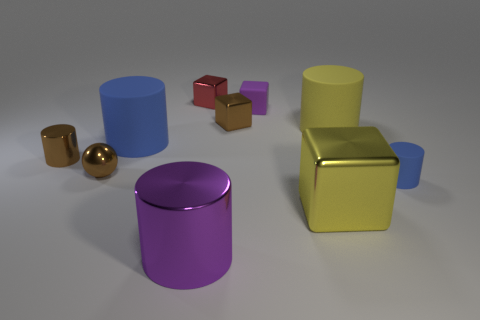Is the small purple thing made of the same material as the cylinder that is in front of the big yellow metal cube?
Give a very brief answer. No. There is a big object that is the same color as the matte cube; what shape is it?
Your answer should be very brief. Cylinder. What number of red shiny blocks have the same size as the purple shiny cylinder?
Ensure brevity in your answer.  0. Is the number of yellow rubber things in front of the large purple shiny cylinder less than the number of gray shiny blocks?
Ensure brevity in your answer.  No. There is a brown metallic cylinder; how many tiny shiny balls are in front of it?
Give a very brief answer. 1. How big is the blue matte thing that is in front of the tiny cylinder on the left side of the small cylinder that is on the right side of the big block?
Provide a short and direct response. Small. Is the shape of the big purple metallic object the same as the rubber object to the left of the purple block?
Your answer should be very brief. Yes. There is a brown cylinder that is made of the same material as the red object; what size is it?
Keep it short and to the point. Small. What material is the large cylinder that is in front of the blue rubber thing that is right of the brown thing that is behind the yellow rubber cylinder made of?
Keep it short and to the point. Metal. What number of metallic things are either large cubes or blue cylinders?
Your answer should be very brief. 1. 